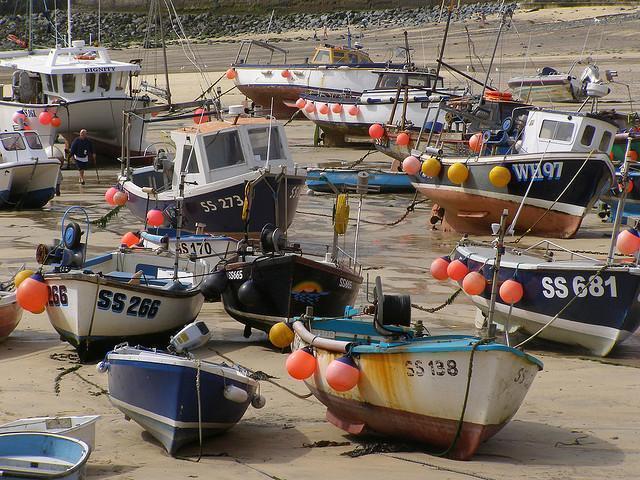What boat number is the largest here?
Pick the correct solution from the four options below to address the question.
Options: 9986, 273, 1812, 681. 681. 